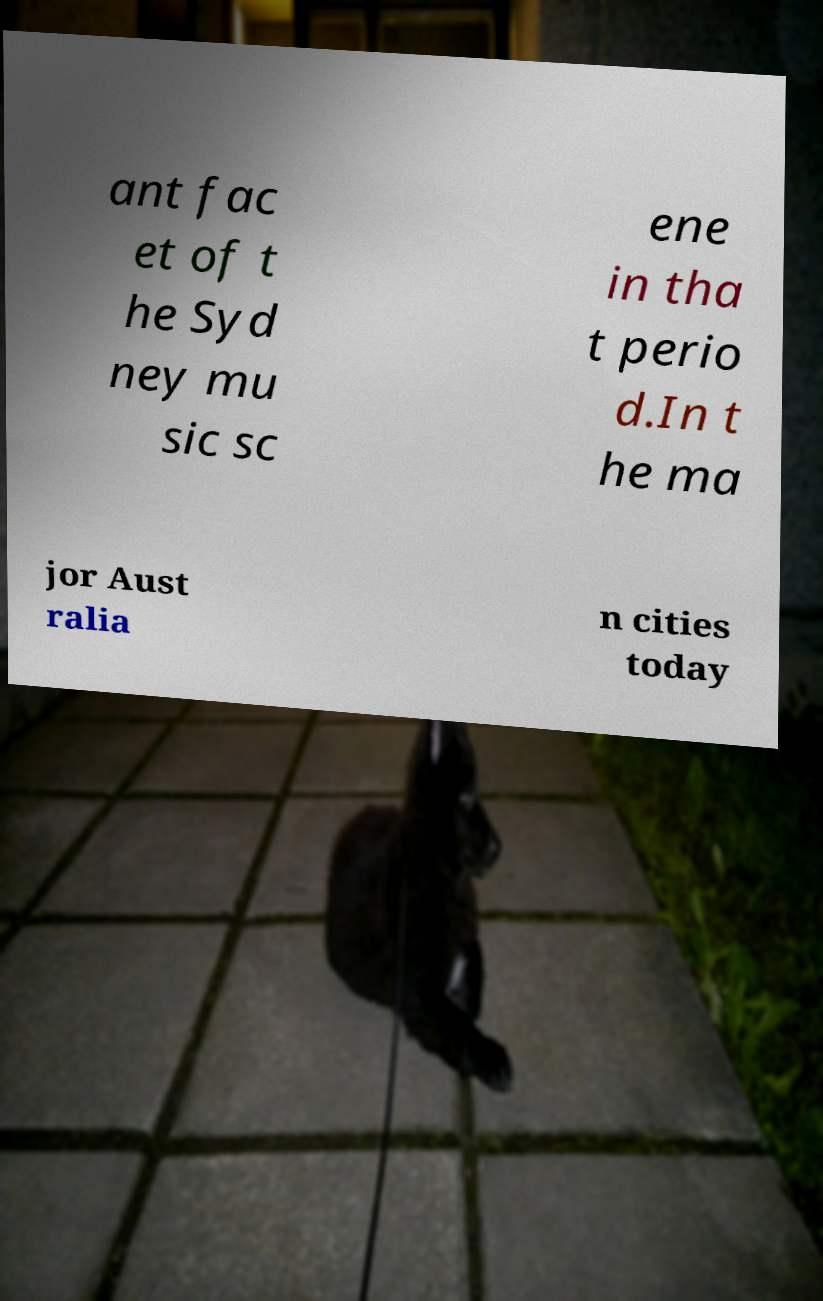Please read and relay the text visible in this image. What does it say? ant fac et of t he Syd ney mu sic sc ene in tha t perio d.In t he ma jor Aust ralia n cities today 